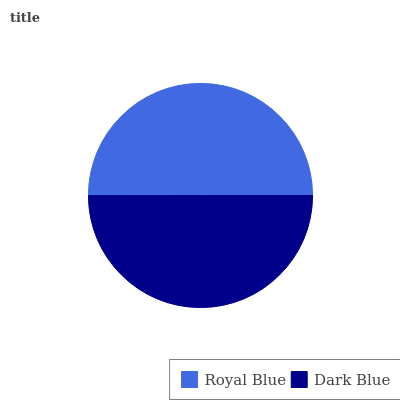Is Dark Blue the minimum?
Answer yes or no. Yes. Is Royal Blue the maximum?
Answer yes or no. Yes. Is Dark Blue the maximum?
Answer yes or no. No. Is Royal Blue greater than Dark Blue?
Answer yes or no. Yes. Is Dark Blue less than Royal Blue?
Answer yes or no. Yes. Is Dark Blue greater than Royal Blue?
Answer yes or no. No. Is Royal Blue less than Dark Blue?
Answer yes or no. No. Is Royal Blue the high median?
Answer yes or no. Yes. Is Dark Blue the low median?
Answer yes or no. Yes. Is Dark Blue the high median?
Answer yes or no. No. Is Royal Blue the low median?
Answer yes or no. No. 